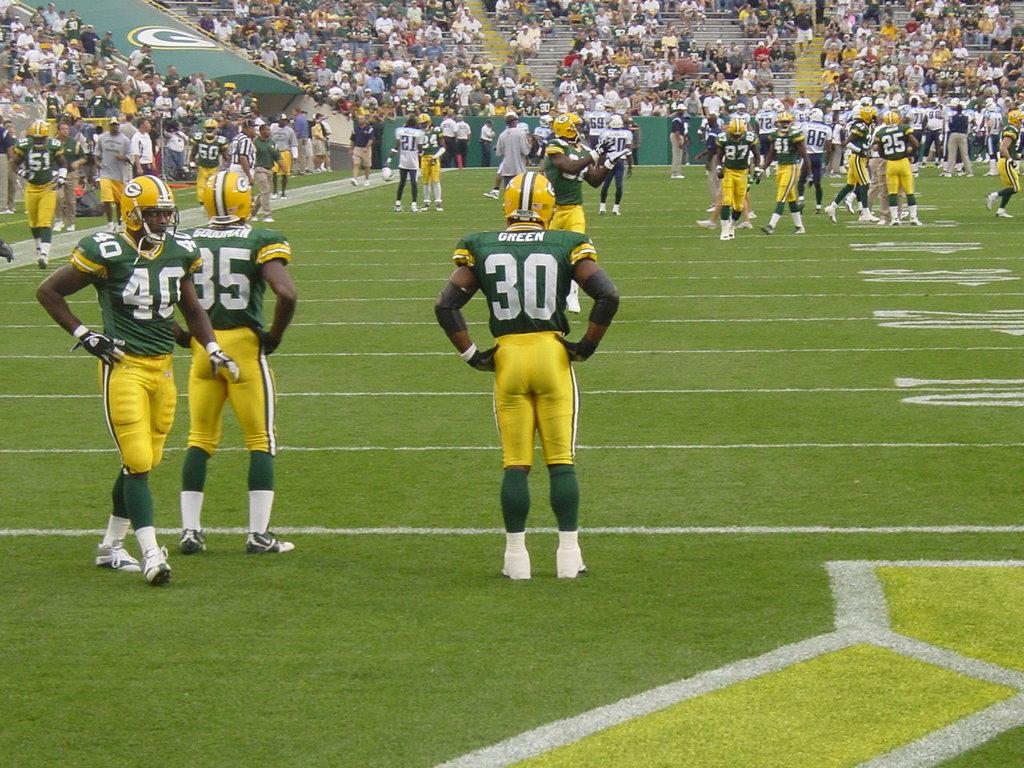What type of people can be seen in the image? There are sportspeople in the image. What is the ground surface like in the image? There is grass visible in the image. Can you describe the people in the image who are not playing sports? There are people standing and people sitting on benches in the image. How many baby ladybugs are crawling on the money in the image? There are no babies, ladybugs, or money present in the image. 